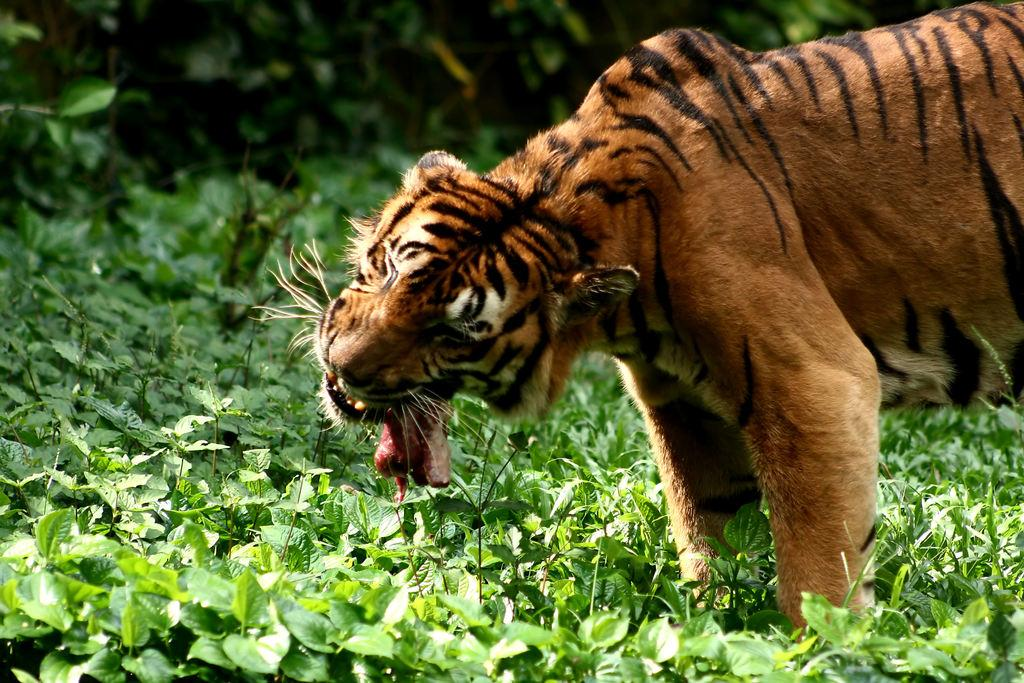What animal is located on the right side of the image? There is a tiger on the right side of the image. What type of vegetation is present at the bottom of the image? There are grass and plants at the bottom of the image. What type of wheel can be seen in the image? There is no wheel present in the image. What type of achiever is depicted in the image? There is no achiever depicted in the image; it features a tiger and vegetation. 